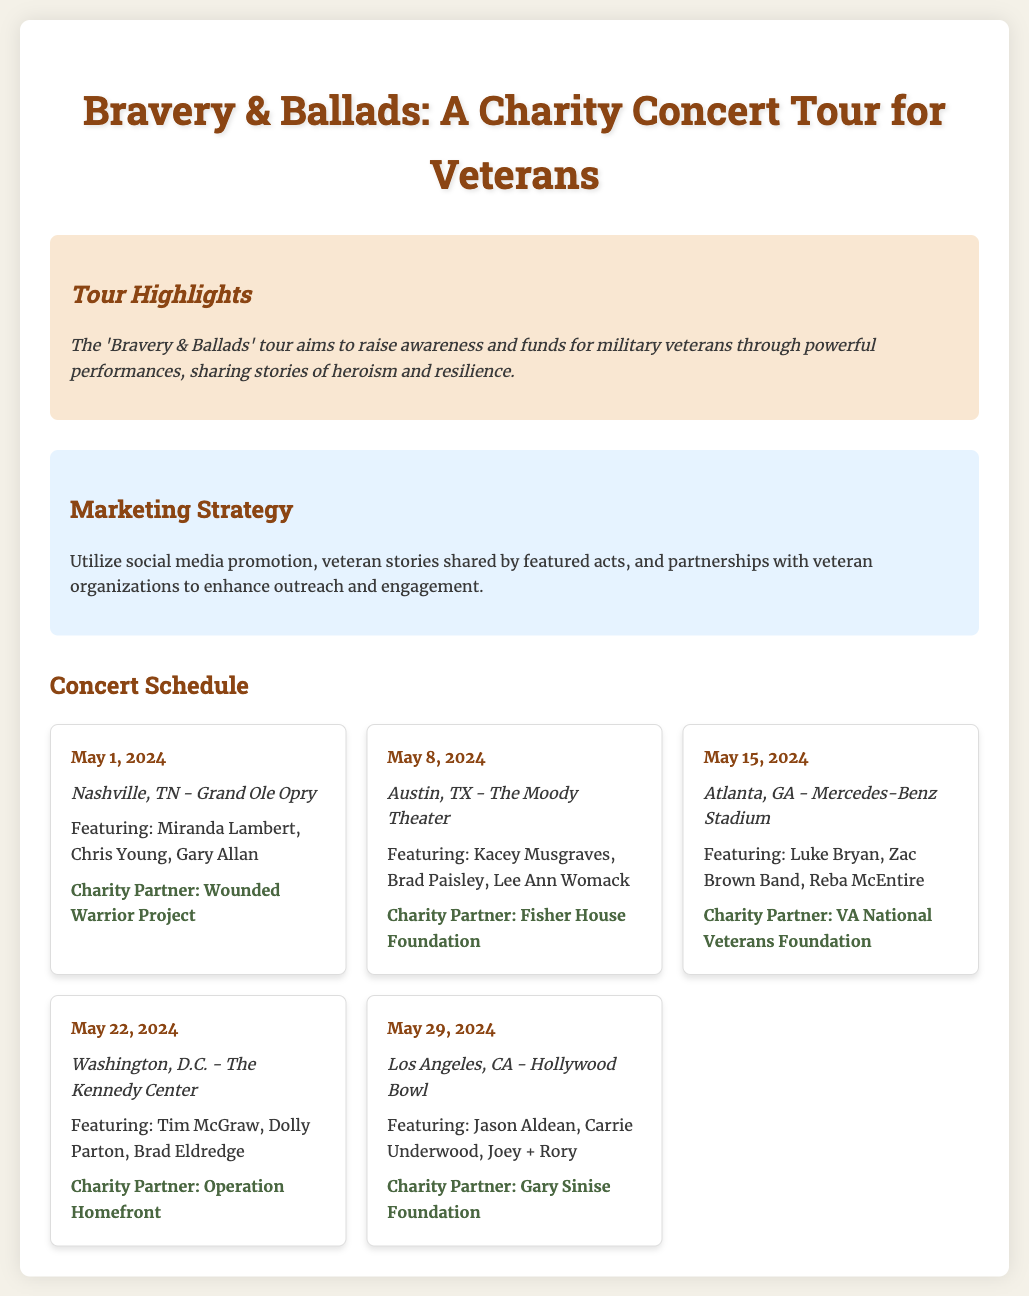What is the title of the tour? The title of the tour is prominently displayed at the top of the document.
Answer: Bravery & Ballads: A Charity Concert Tour for Veterans How many concerts are scheduled? By counting the concert cards, we can determine the total number of concerts scheduled in the document.
Answer: Five What is the date of the concert in Nashville? The date is explicitly mentioned in the concert card for Nashville.
Answer: May 1, 2024 Which venue will host the concert in Washington, D.C.? The venue for the Washington, D.C. concert is specified in the respective concert card.
Answer: The Kennedy Center Who are two featured acts for the concert in Los Angeles, CA? The featured acts for that concert are listed in the concert card.
Answer: Jason Aldean, Carrie Underwood What charity partner is associated with the Atlanta concert? The charity partner is mentioned in the concert card for Atlanta.
Answer: VA National Veterans Foundation Which act is performing in both Nashville and Washington, D.C.? By comparing the featured acts of both locations, we find common names.
Answer: Brad Paisley Which location has the concert with Kacey Musgraves? The location is stated in the concert card where Kacey Musgraves is mentioned.
Answer: Austin, TX What marketing strategy is mentioned in the document? The document includes a section about marketing strategy with specific approaches outlined.
Answer: Utilize social media promotion 